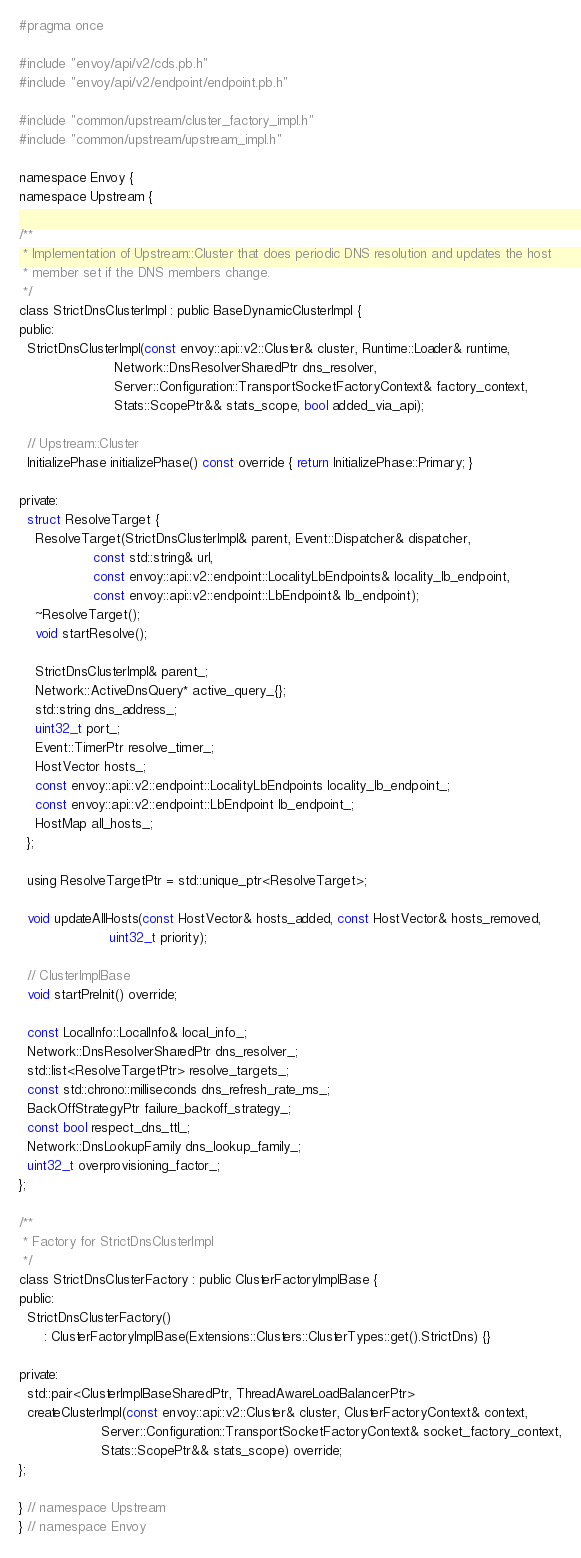<code> <loc_0><loc_0><loc_500><loc_500><_C_>#pragma once

#include "envoy/api/v2/cds.pb.h"
#include "envoy/api/v2/endpoint/endpoint.pb.h"

#include "common/upstream/cluster_factory_impl.h"
#include "common/upstream/upstream_impl.h"

namespace Envoy {
namespace Upstream {

/**
 * Implementation of Upstream::Cluster that does periodic DNS resolution and updates the host
 * member set if the DNS members change.
 */
class StrictDnsClusterImpl : public BaseDynamicClusterImpl {
public:
  StrictDnsClusterImpl(const envoy::api::v2::Cluster& cluster, Runtime::Loader& runtime,
                       Network::DnsResolverSharedPtr dns_resolver,
                       Server::Configuration::TransportSocketFactoryContext& factory_context,
                       Stats::ScopePtr&& stats_scope, bool added_via_api);

  // Upstream::Cluster
  InitializePhase initializePhase() const override { return InitializePhase::Primary; }

private:
  struct ResolveTarget {
    ResolveTarget(StrictDnsClusterImpl& parent, Event::Dispatcher& dispatcher,
                  const std::string& url,
                  const envoy::api::v2::endpoint::LocalityLbEndpoints& locality_lb_endpoint,
                  const envoy::api::v2::endpoint::LbEndpoint& lb_endpoint);
    ~ResolveTarget();
    void startResolve();

    StrictDnsClusterImpl& parent_;
    Network::ActiveDnsQuery* active_query_{};
    std::string dns_address_;
    uint32_t port_;
    Event::TimerPtr resolve_timer_;
    HostVector hosts_;
    const envoy::api::v2::endpoint::LocalityLbEndpoints locality_lb_endpoint_;
    const envoy::api::v2::endpoint::LbEndpoint lb_endpoint_;
    HostMap all_hosts_;
  };

  using ResolveTargetPtr = std::unique_ptr<ResolveTarget>;

  void updateAllHosts(const HostVector& hosts_added, const HostVector& hosts_removed,
                      uint32_t priority);

  // ClusterImplBase
  void startPreInit() override;

  const LocalInfo::LocalInfo& local_info_;
  Network::DnsResolverSharedPtr dns_resolver_;
  std::list<ResolveTargetPtr> resolve_targets_;
  const std::chrono::milliseconds dns_refresh_rate_ms_;
  BackOffStrategyPtr failure_backoff_strategy_;
  const bool respect_dns_ttl_;
  Network::DnsLookupFamily dns_lookup_family_;
  uint32_t overprovisioning_factor_;
};

/**
 * Factory for StrictDnsClusterImpl
 */
class StrictDnsClusterFactory : public ClusterFactoryImplBase {
public:
  StrictDnsClusterFactory()
      : ClusterFactoryImplBase(Extensions::Clusters::ClusterTypes::get().StrictDns) {}

private:
  std::pair<ClusterImplBaseSharedPtr, ThreadAwareLoadBalancerPtr>
  createClusterImpl(const envoy::api::v2::Cluster& cluster, ClusterFactoryContext& context,
                    Server::Configuration::TransportSocketFactoryContext& socket_factory_context,
                    Stats::ScopePtr&& stats_scope) override;
};

} // namespace Upstream
} // namespace Envoy
</code> 